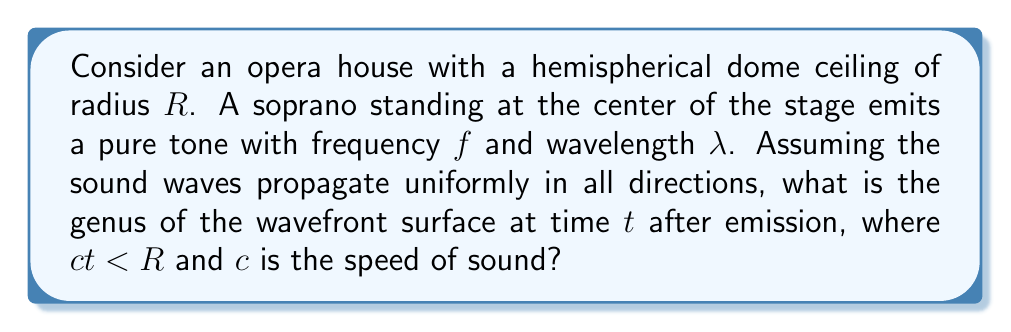Show me your answer to this math problem. To solve this problem, we need to analyze the topology of the wavefront as it expands over time:

1) At time $t$ after emission, the wavefront forms a sphere with radius $r = ct$, centered at the source (the soprano).

2) The sphere has not yet reached the dome ceiling since $ct < R$.

3) In topology, a sphere is a closed surface with no holes. It can be continuously deformed into any other closed surface with no holes, such as a cube or an ellipsoid.

4) The genus of a surface is a topological invariant that represents the number of holes or "handles" the surface has. For a sphere, there are no holes.

5) The genus $g$ of a surface can be calculated using the Euler characteristic $\chi$ and the formula:

   $$\chi = 2 - 2g$$

6) For a sphere, the Euler characteristic $\chi = 2$.

7) Solving for $g$:

   $$2 = 2 - 2g$$
   $$2g = 0$$
   $$g = 0$$

Therefore, the genus of the wavefront surface is 0.
Answer: The genus of the wavefront surface is 0. 